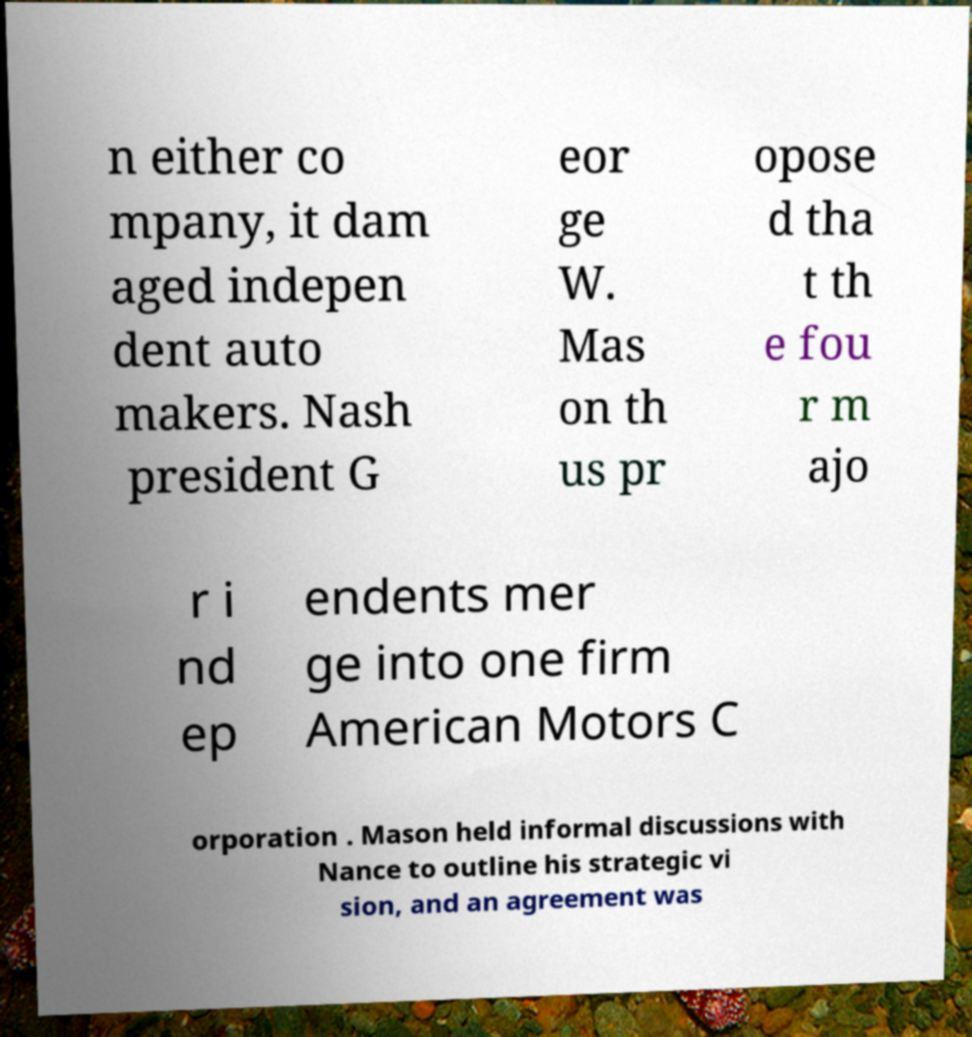Please identify and transcribe the text found in this image. n either co mpany, it dam aged indepen dent auto makers. Nash president G eor ge W. Mas on th us pr opose d tha t th e fou r m ajo r i nd ep endents mer ge into one firm American Motors C orporation . Mason held informal discussions with Nance to outline his strategic vi sion, and an agreement was 